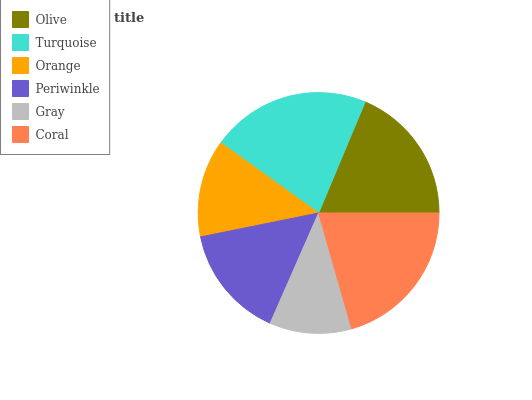Is Gray the minimum?
Answer yes or no. Yes. Is Turquoise the maximum?
Answer yes or no. Yes. Is Orange the minimum?
Answer yes or no. No. Is Orange the maximum?
Answer yes or no. No. Is Turquoise greater than Orange?
Answer yes or no. Yes. Is Orange less than Turquoise?
Answer yes or no. Yes. Is Orange greater than Turquoise?
Answer yes or no. No. Is Turquoise less than Orange?
Answer yes or no. No. Is Olive the high median?
Answer yes or no. Yes. Is Periwinkle the low median?
Answer yes or no. Yes. Is Gray the high median?
Answer yes or no. No. Is Coral the low median?
Answer yes or no. No. 